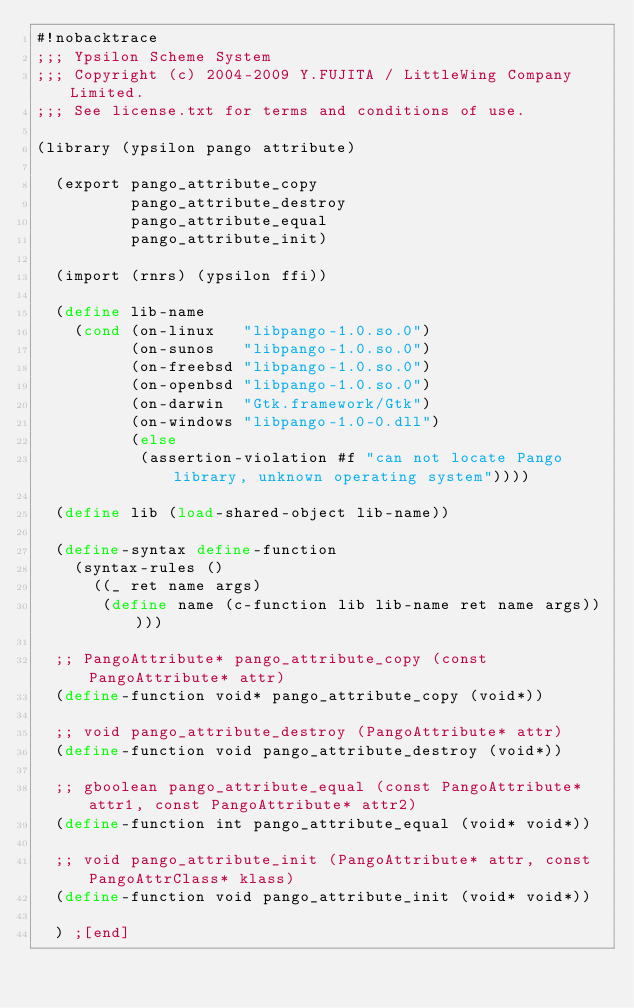Convert code to text. <code><loc_0><loc_0><loc_500><loc_500><_Scheme_>#!nobacktrace
;;; Ypsilon Scheme System
;;; Copyright (c) 2004-2009 Y.FUJITA / LittleWing Company Limited.
;;; See license.txt for terms and conditions of use.

(library (ypsilon pango attribute)

  (export pango_attribute_copy
          pango_attribute_destroy
          pango_attribute_equal
          pango_attribute_init)

  (import (rnrs) (ypsilon ffi))

  (define lib-name
    (cond (on-linux   "libpango-1.0.so.0")
          (on-sunos   "libpango-1.0.so.0")
          (on-freebsd "libpango-1.0.so.0")
          (on-openbsd "libpango-1.0.so.0")
          (on-darwin  "Gtk.framework/Gtk")
          (on-windows "libpango-1.0-0.dll")
          (else
           (assertion-violation #f "can not locate Pango library, unknown operating system"))))

  (define lib (load-shared-object lib-name))

  (define-syntax define-function
    (syntax-rules ()
      ((_ ret name args)
       (define name (c-function lib lib-name ret name args)))))

  ;; PangoAttribute* pango_attribute_copy (const PangoAttribute* attr)
  (define-function void* pango_attribute_copy (void*))

  ;; void pango_attribute_destroy (PangoAttribute* attr)
  (define-function void pango_attribute_destroy (void*))

  ;; gboolean pango_attribute_equal (const PangoAttribute* attr1, const PangoAttribute* attr2)
  (define-function int pango_attribute_equal (void* void*))

  ;; void pango_attribute_init (PangoAttribute* attr, const PangoAttrClass* klass)
  (define-function void pango_attribute_init (void* void*))

  ) ;[end]
</code> 